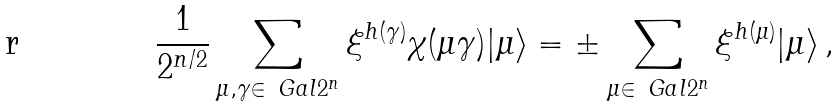Convert formula to latex. <formula><loc_0><loc_0><loc_500><loc_500>\frac { 1 } { 2 ^ { n / 2 } } \sum _ { \mu , \gamma \in \ G a l { 2 ^ { n } } } \xi ^ { h ( \gamma ) } \chi ( \mu \gamma ) | \mu \rangle = \pm \sum _ { \mu \in \ G a l { 2 ^ { n } } } \xi ^ { h ( \mu ) } | \mu \rangle \, ,</formula> 